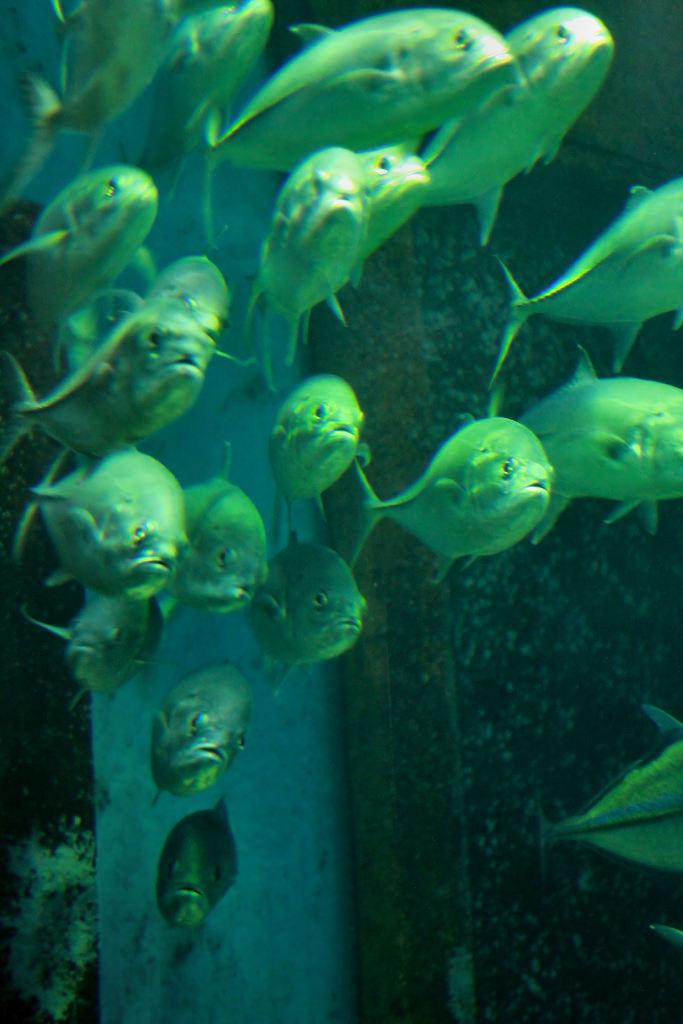What type of animals can be seen in the image? Fish are visible in the image. Where are the fish located? The fish are under the water. What type of vein is visible in the image? There is no vein present in the image; it features fish underwater. Is there a doll present in the image? No, there is no doll in the image. 